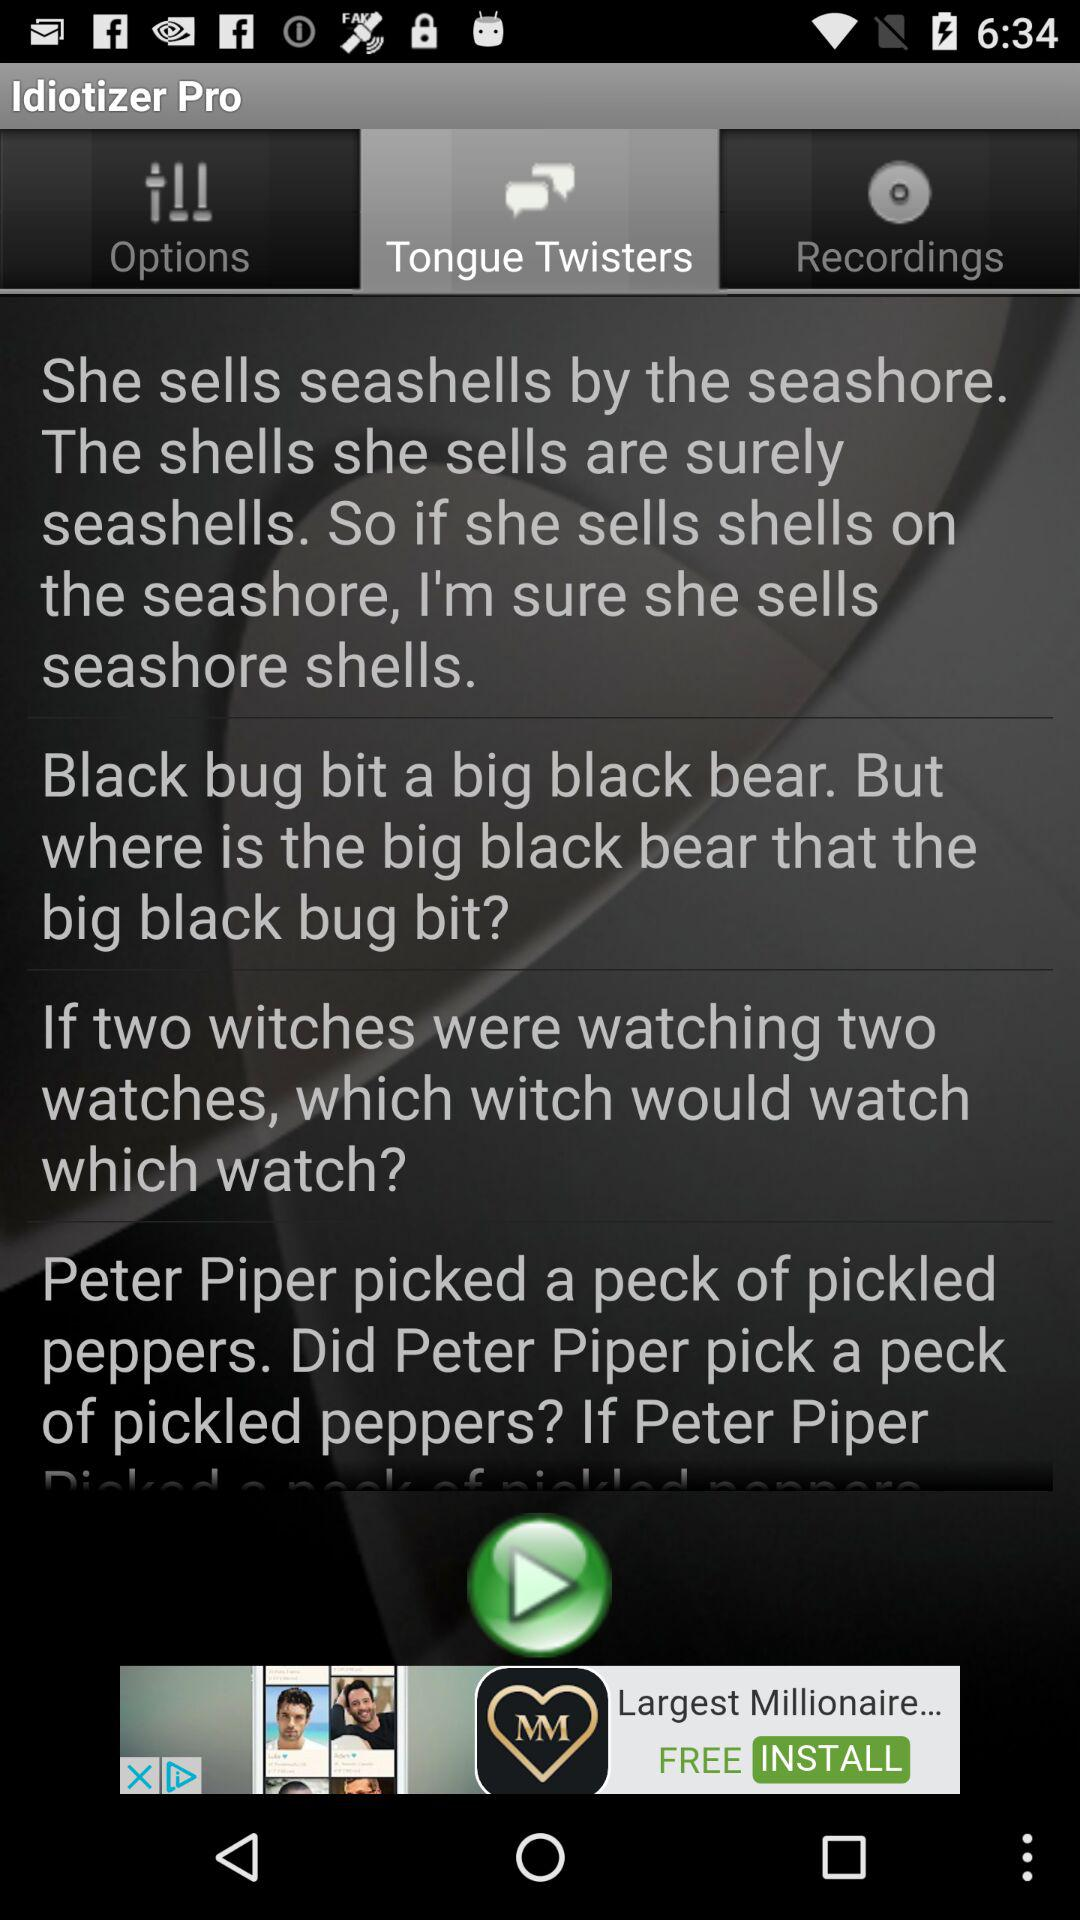What is the name of the application? The name of the application is "Idiotizer Pro". 